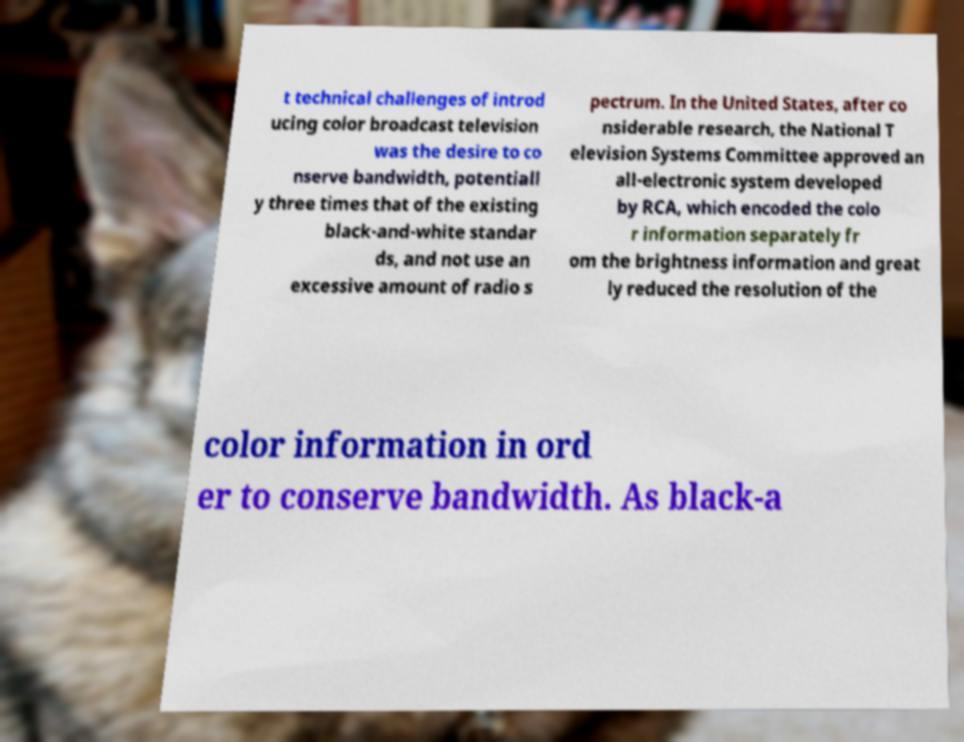I need the written content from this picture converted into text. Can you do that? t technical challenges of introd ucing color broadcast television was the desire to co nserve bandwidth, potentiall y three times that of the existing black-and-white standar ds, and not use an excessive amount of radio s pectrum. In the United States, after co nsiderable research, the National T elevision Systems Committee approved an all-electronic system developed by RCA, which encoded the colo r information separately fr om the brightness information and great ly reduced the resolution of the color information in ord er to conserve bandwidth. As black-a 